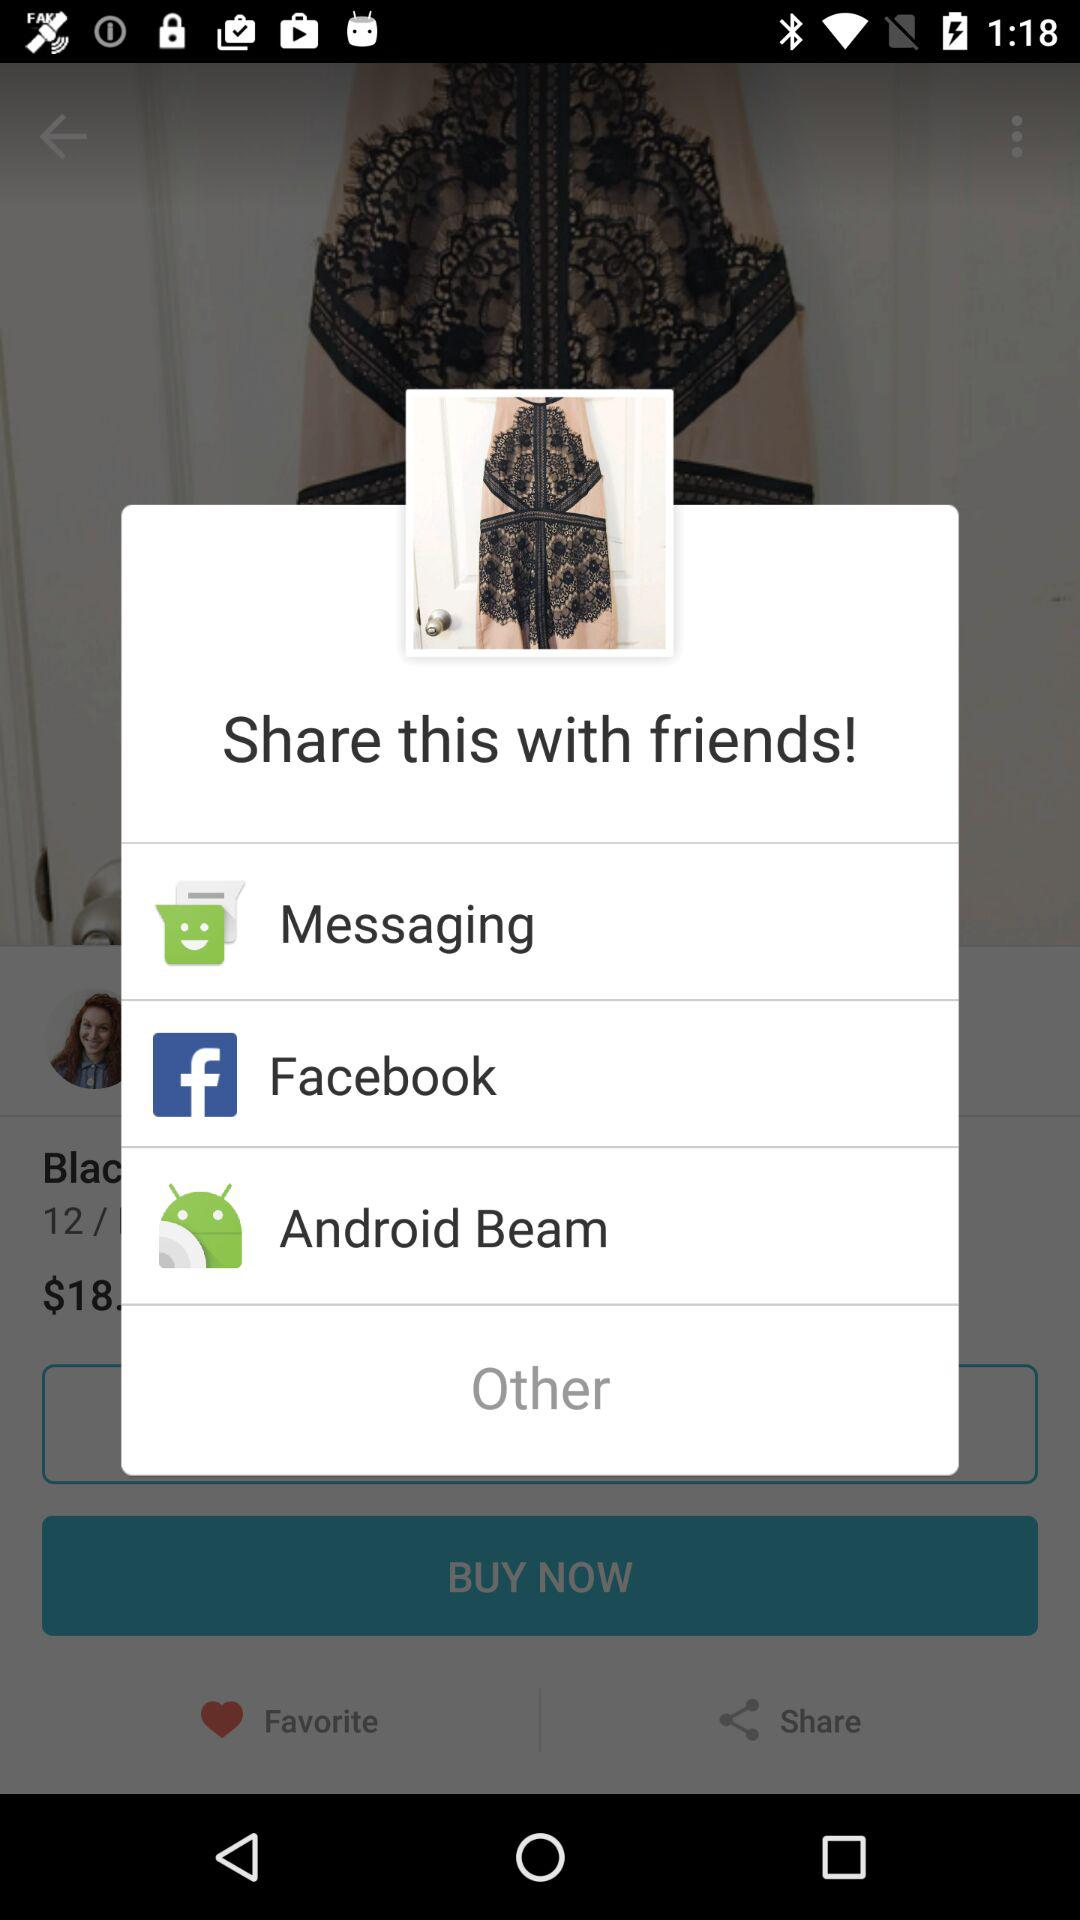What are the options to share? The options are "Messaging", "Facebook" and "Android Beam". 